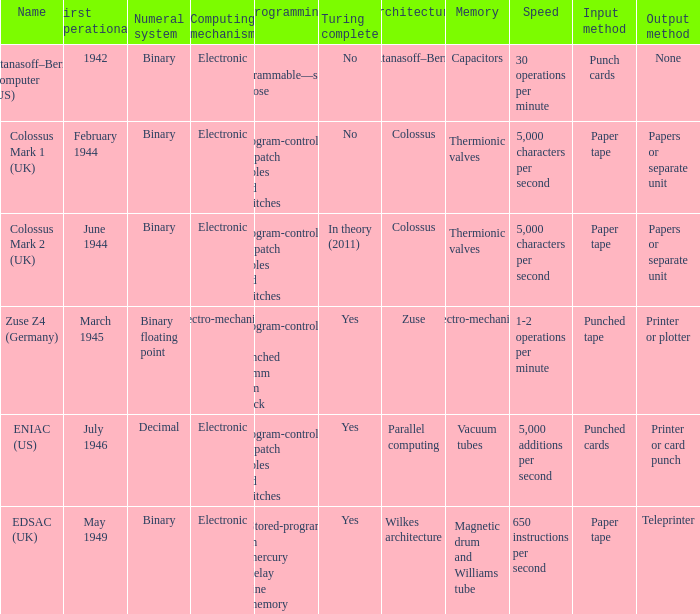What's the computing mechanbeingm with first operational being february 1944 Electronic. 